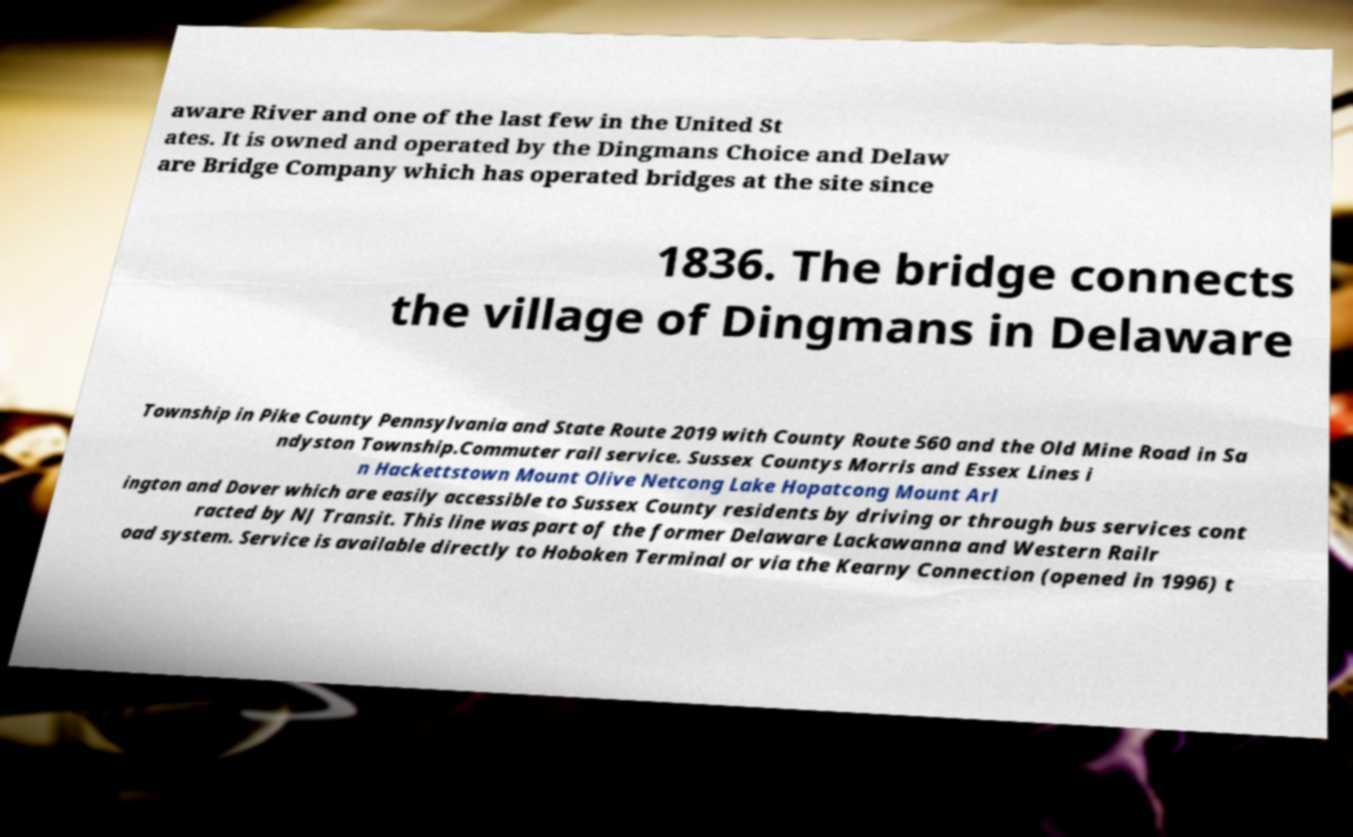There's text embedded in this image that I need extracted. Can you transcribe it verbatim? aware River and one of the last few in the United St ates. It is owned and operated by the Dingmans Choice and Delaw are Bridge Company which has operated bridges at the site since 1836. The bridge connects the village of Dingmans in Delaware Township in Pike County Pennsylvania and State Route 2019 with County Route 560 and the Old Mine Road in Sa ndyston Township.Commuter rail service. Sussex Countys Morris and Essex Lines i n Hackettstown Mount Olive Netcong Lake Hopatcong Mount Arl ington and Dover which are easily accessible to Sussex County residents by driving or through bus services cont racted by NJ Transit. This line was part of the former Delaware Lackawanna and Western Railr oad system. Service is available directly to Hoboken Terminal or via the Kearny Connection (opened in 1996) t 